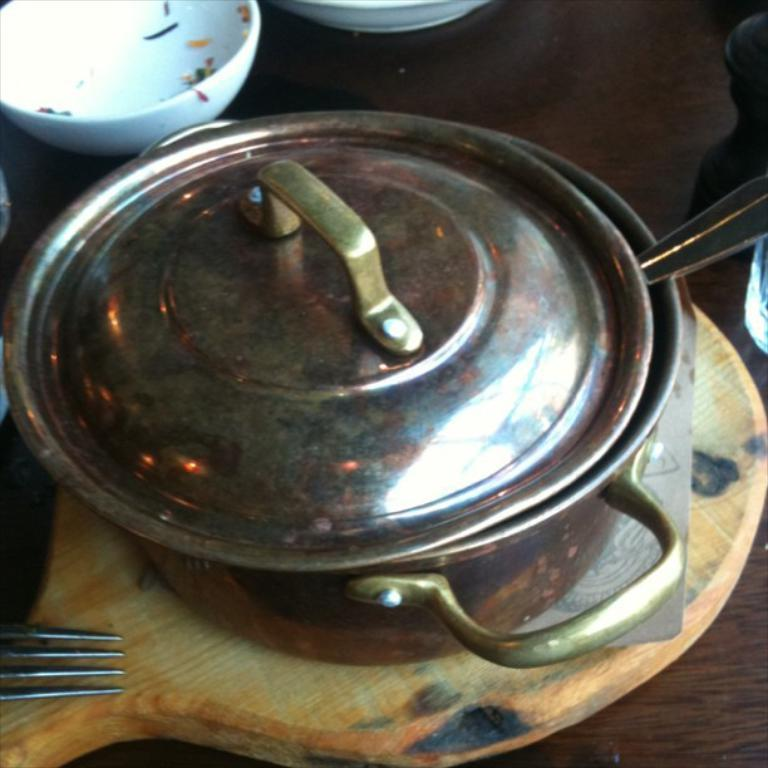What is inside the bowl that is visible in the image? There is a spoon inside the bowl that is visible in the image. What is the bowl placed on in the image? The bowl is on a wooden pan in the image. What other utensil is present near the bowl on the wooden pan? There is a fork above the bowl on the wooden pan. Where are these objects located in the image? The objects are on a table in the image. Are there any other bowls visible in the image? Yes, there are additional bowls beside the bowl with the spoon and fork. Can you hear the earth moving in the image? There is no indication of the earth moving or any sounds in the image. 